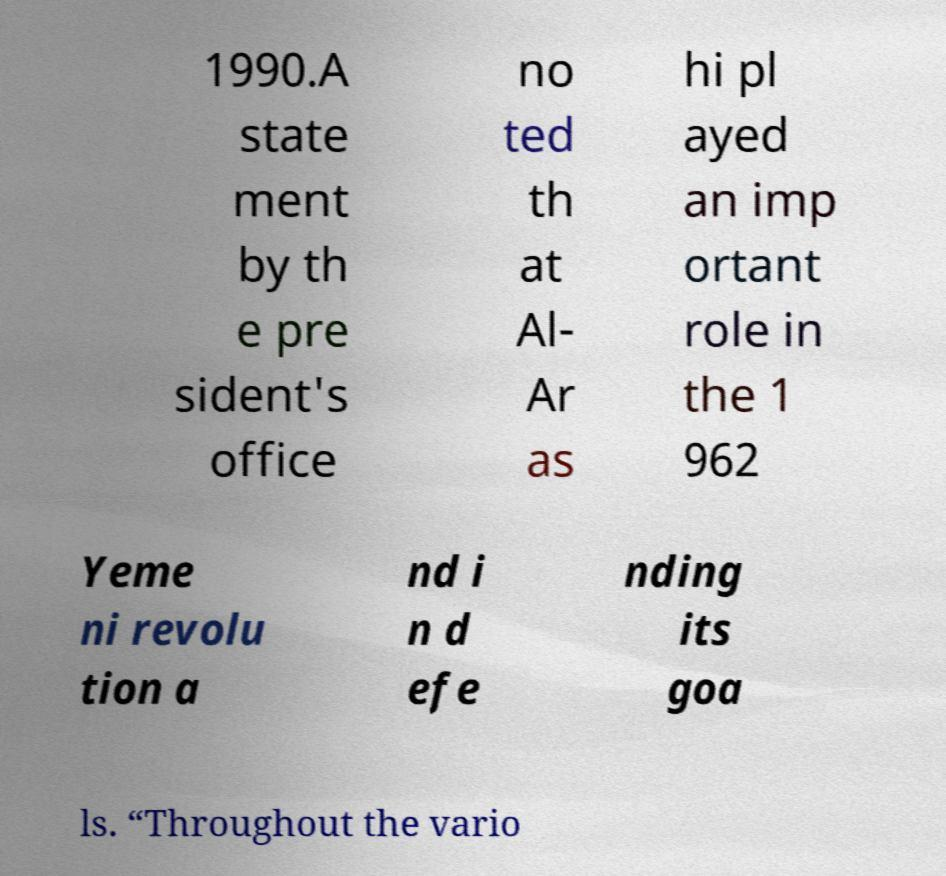There's text embedded in this image that I need extracted. Can you transcribe it verbatim? 1990.A state ment by th e pre sident's office no ted th at Al- Ar as hi pl ayed an imp ortant role in the 1 962 Yeme ni revolu tion a nd i n d efe nding its goa ls. “Throughout the vario 